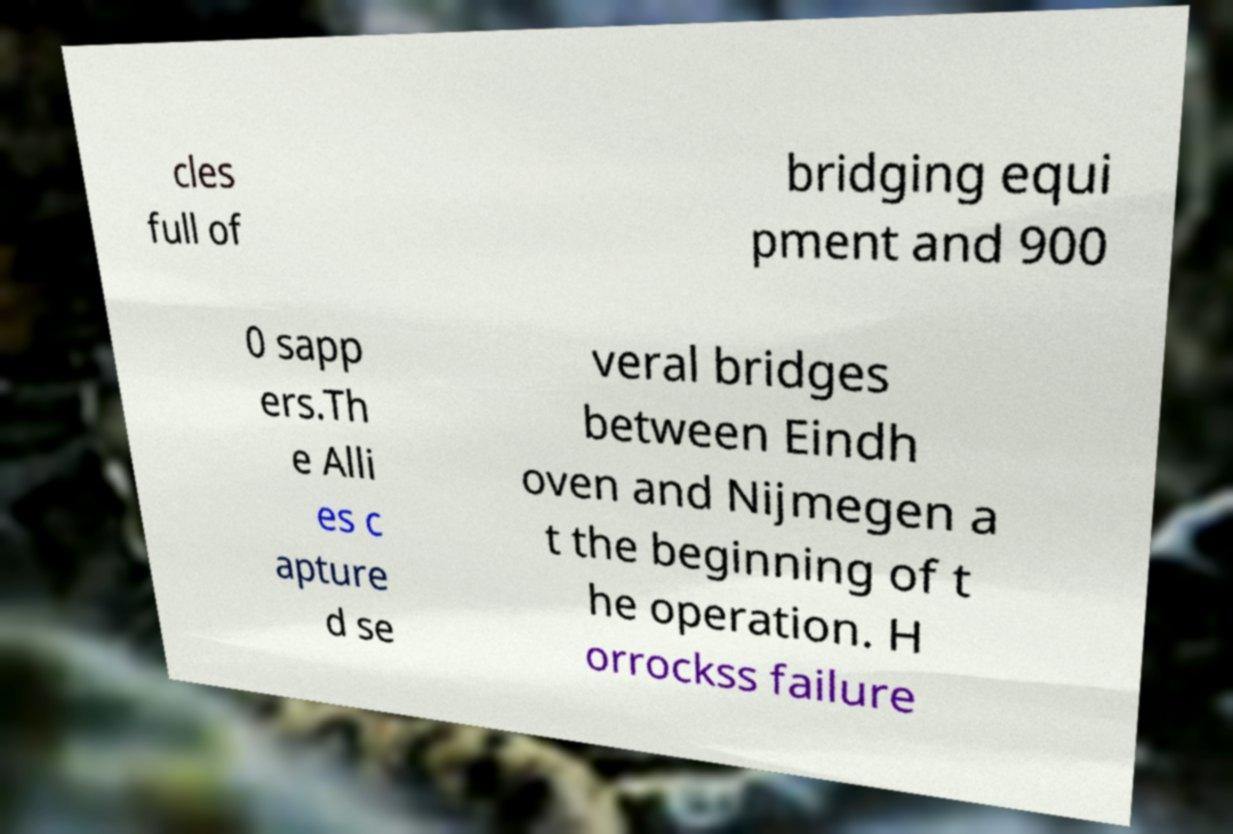I need the written content from this picture converted into text. Can you do that? cles full of bridging equi pment and 900 0 sapp ers.Th e Alli es c apture d se veral bridges between Eindh oven and Nijmegen a t the beginning of t he operation. H orrockss failure 